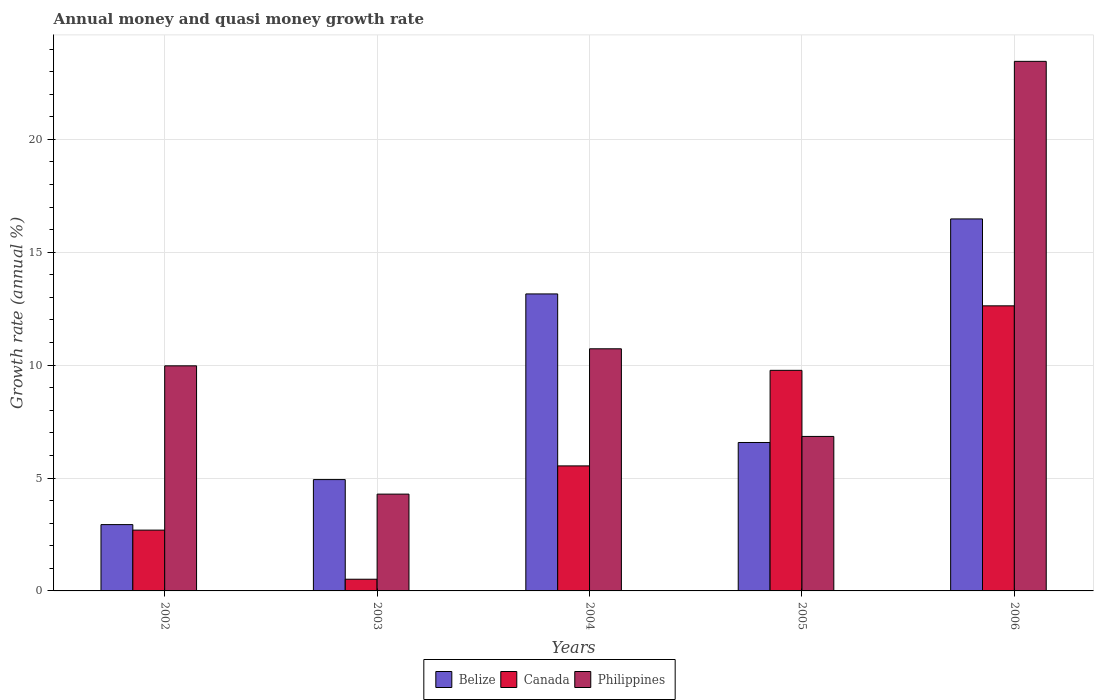How many different coloured bars are there?
Your answer should be very brief. 3. How many groups of bars are there?
Keep it short and to the point. 5. Are the number of bars on each tick of the X-axis equal?
Offer a very short reply. Yes. How many bars are there on the 1st tick from the left?
Offer a terse response. 3. How many bars are there on the 3rd tick from the right?
Provide a succinct answer. 3. What is the label of the 1st group of bars from the left?
Provide a short and direct response. 2002. In how many cases, is the number of bars for a given year not equal to the number of legend labels?
Provide a succinct answer. 0. What is the growth rate in Philippines in 2005?
Your answer should be very brief. 6.84. Across all years, what is the maximum growth rate in Canada?
Your answer should be compact. 12.63. Across all years, what is the minimum growth rate in Canada?
Keep it short and to the point. 0.52. In which year was the growth rate in Belize maximum?
Your answer should be very brief. 2006. In which year was the growth rate in Belize minimum?
Ensure brevity in your answer.  2002. What is the total growth rate in Belize in the graph?
Offer a terse response. 44.07. What is the difference between the growth rate in Philippines in 2002 and that in 2006?
Offer a very short reply. -13.49. What is the difference between the growth rate in Philippines in 2005 and the growth rate in Canada in 2004?
Provide a short and direct response. 1.3. What is the average growth rate in Philippines per year?
Offer a terse response. 11.05. In the year 2006, what is the difference between the growth rate in Canada and growth rate in Belize?
Your answer should be compact. -3.85. What is the ratio of the growth rate in Belize in 2004 to that in 2006?
Offer a very short reply. 0.8. Is the growth rate in Philippines in 2003 less than that in 2006?
Your answer should be very brief. Yes. What is the difference between the highest and the second highest growth rate in Canada?
Offer a terse response. 2.86. What is the difference between the highest and the lowest growth rate in Canada?
Keep it short and to the point. 12.11. In how many years, is the growth rate in Canada greater than the average growth rate in Canada taken over all years?
Your response must be concise. 2. What does the 1st bar from the left in 2005 represents?
Your answer should be compact. Belize. How many bars are there?
Your response must be concise. 15. Are all the bars in the graph horizontal?
Provide a succinct answer. No. How many years are there in the graph?
Make the answer very short. 5. Are the values on the major ticks of Y-axis written in scientific E-notation?
Offer a very short reply. No. Does the graph contain grids?
Offer a very short reply. Yes. Where does the legend appear in the graph?
Ensure brevity in your answer.  Bottom center. What is the title of the graph?
Give a very brief answer. Annual money and quasi money growth rate. Does "Ethiopia" appear as one of the legend labels in the graph?
Provide a short and direct response. No. What is the label or title of the X-axis?
Your answer should be very brief. Years. What is the label or title of the Y-axis?
Ensure brevity in your answer.  Growth rate (annual %). What is the Growth rate (annual %) in Belize in 2002?
Offer a very short reply. 2.94. What is the Growth rate (annual %) in Canada in 2002?
Offer a terse response. 2.69. What is the Growth rate (annual %) of Philippines in 2002?
Give a very brief answer. 9.97. What is the Growth rate (annual %) of Belize in 2003?
Offer a terse response. 4.93. What is the Growth rate (annual %) of Canada in 2003?
Offer a terse response. 0.52. What is the Growth rate (annual %) of Philippines in 2003?
Your response must be concise. 4.29. What is the Growth rate (annual %) of Belize in 2004?
Your answer should be compact. 13.15. What is the Growth rate (annual %) of Canada in 2004?
Your answer should be very brief. 5.54. What is the Growth rate (annual %) in Philippines in 2004?
Offer a terse response. 10.72. What is the Growth rate (annual %) of Belize in 2005?
Offer a very short reply. 6.57. What is the Growth rate (annual %) in Canada in 2005?
Your answer should be very brief. 9.77. What is the Growth rate (annual %) in Philippines in 2005?
Ensure brevity in your answer.  6.84. What is the Growth rate (annual %) in Belize in 2006?
Your response must be concise. 16.48. What is the Growth rate (annual %) of Canada in 2006?
Your response must be concise. 12.63. What is the Growth rate (annual %) of Philippines in 2006?
Offer a very short reply. 23.45. Across all years, what is the maximum Growth rate (annual %) in Belize?
Offer a terse response. 16.48. Across all years, what is the maximum Growth rate (annual %) in Canada?
Your response must be concise. 12.63. Across all years, what is the maximum Growth rate (annual %) in Philippines?
Offer a very short reply. 23.45. Across all years, what is the minimum Growth rate (annual %) in Belize?
Ensure brevity in your answer.  2.94. Across all years, what is the minimum Growth rate (annual %) of Canada?
Give a very brief answer. 0.52. Across all years, what is the minimum Growth rate (annual %) in Philippines?
Your response must be concise. 4.29. What is the total Growth rate (annual %) in Belize in the graph?
Provide a succinct answer. 44.07. What is the total Growth rate (annual %) in Canada in the graph?
Your answer should be compact. 31.14. What is the total Growth rate (annual %) of Philippines in the graph?
Your response must be concise. 55.27. What is the difference between the Growth rate (annual %) of Belize in 2002 and that in 2003?
Provide a short and direct response. -1.99. What is the difference between the Growth rate (annual %) in Canada in 2002 and that in 2003?
Give a very brief answer. 2.18. What is the difference between the Growth rate (annual %) of Philippines in 2002 and that in 2003?
Provide a succinct answer. 5.68. What is the difference between the Growth rate (annual %) of Belize in 2002 and that in 2004?
Ensure brevity in your answer.  -10.22. What is the difference between the Growth rate (annual %) in Canada in 2002 and that in 2004?
Provide a succinct answer. -2.84. What is the difference between the Growth rate (annual %) in Philippines in 2002 and that in 2004?
Offer a terse response. -0.75. What is the difference between the Growth rate (annual %) in Belize in 2002 and that in 2005?
Keep it short and to the point. -3.64. What is the difference between the Growth rate (annual %) in Canada in 2002 and that in 2005?
Your answer should be compact. -7.08. What is the difference between the Growth rate (annual %) of Philippines in 2002 and that in 2005?
Ensure brevity in your answer.  3.13. What is the difference between the Growth rate (annual %) of Belize in 2002 and that in 2006?
Give a very brief answer. -13.54. What is the difference between the Growth rate (annual %) of Canada in 2002 and that in 2006?
Your answer should be compact. -9.93. What is the difference between the Growth rate (annual %) of Philippines in 2002 and that in 2006?
Offer a terse response. -13.49. What is the difference between the Growth rate (annual %) in Belize in 2003 and that in 2004?
Make the answer very short. -8.22. What is the difference between the Growth rate (annual %) in Canada in 2003 and that in 2004?
Keep it short and to the point. -5.02. What is the difference between the Growth rate (annual %) of Philippines in 2003 and that in 2004?
Give a very brief answer. -6.44. What is the difference between the Growth rate (annual %) of Belize in 2003 and that in 2005?
Offer a terse response. -1.64. What is the difference between the Growth rate (annual %) in Canada in 2003 and that in 2005?
Make the answer very short. -9.25. What is the difference between the Growth rate (annual %) in Philippines in 2003 and that in 2005?
Provide a succinct answer. -2.55. What is the difference between the Growth rate (annual %) in Belize in 2003 and that in 2006?
Make the answer very short. -11.54. What is the difference between the Growth rate (annual %) of Canada in 2003 and that in 2006?
Keep it short and to the point. -12.11. What is the difference between the Growth rate (annual %) in Philippines in 2003 and that in 2006?
Make the answer very short. -19.17. What is the difference between the Growth rate (annual %) in Belize in 2004 and that in 2005?
Keep it short and to the point. 6.58. What is the difference between the Growth rate (annual %) of Canada in 2004 and that in 2005?
Keep it short and to the point. -4.23. What is the difference between the Growth rate (annual %) of Philippines in 2004 and that in 2005?
Ensure brevity in your answer.  3.88. What is the difference between the Growth rate (annual %) of Belize in 2004 and that in 2006?
Give a very brief answer. -3.32. What is the difference between the Growth rate (annual %) in Canada in 2004 and that in 2006?
Offer a terse response. -7.09. What is the difference between the Growth rate (annual %) in Philippines in 2004 and that in 2006?
Offer a terse response. -12.73. What is the difference between the Growth rate (annual %) in Belize in 2005 and that in 2006?
Give a very brief answer. -9.9. What is the difference between the Growth rate (annual %) of Canada in 2005 and that in 2006?
Offer a very short reply. -2.86. What is the difference between the Growth rate (annual %) in Philippines in 2005 and that in 2006?
Your answer should be compact. -16.61. What is the difference between the Growth rate (annual %) of Belize in 2002 and the Growth rate (annual %) of Canada in 2003?
Your response must be concise. 2.42. What is the difference between the Growth rate (annual %) in Belize in 2002 and the Growth rate (annual %) in Philippines in 2003?
Your answer should be very brief. -1.35. What is the difference between the Growth rate (annual %) in Canada in 2002 and the Growth rate (annual %) in Philippines in 2003?
Provide a short and direct response. -1.59. What is the difference between the Growth rate (annual %) of Belize in 2002 and the Growth rate (annual %) of Canada in 2004?
Offer a very short reply. -2.6. What is the difference between the Growth rate (annual %) in Belize in 2002 and the Growth rate (annual %) in Philippines in 2004?
Your answer should be very brief. -7.79. What is the difference between the Growth rate (annual %) of Canada in 2002 and the Growth rate (annual %) of Philippines in 2004?
Ensure brevity in your answer.  -8.03. What is the difference between the Growth rate (annual %) in Belize in 2002 and the Growth rate (annual %) in Canada in 2005?
Offer a very short reply. -6.83. What is the difference between the Growth rate (annual %) in Belize in 2002 and the Growth rate (annual %) in Philippines in 2005?
Give a very brief answer. -3.91. What is the difference between the Growth rate (annual %) in Canada in 2002 and the Growth rate (annual %) in Philippines in 2005?
Your answer should be compact. -4.15. What is the difference between the Growth rate (annual %) in Belize in 2002 and the Growth rate (annual %) in Canada in 2006?
Your response must be concise. -9.69. What is the difference between the Growth rate (annual %) in Belize in 2002 and the Growth rate (annual %) in Philippines in 2006?
Ensure brevity in your answer.  -20.52. What is the difference between the Growth rate (annual %) of Canada in 2002 and the Growth rate (annual %) of Philippines in 2006?
Provide a succinct answer. -20.76. What is the difference between the Growth rate (annual %) of Belize in 2003 and the Growth rate (annual %) of Canada in 2004?
Your answer should be compact. -0.61. What is the difference between the Growth rate (annual %) in Belize in 2003 and the Growth rate (annual %) in Philippines in 2004?
Offer a very short reply. -5.79. What is the difference between the Growth rate (annual %) in Canada in 2003 and the Growth rate (annual %) in Philippines in 2004?
Make the answer very short. -10.21. What is the difference between the Growth rate (annual %) of Belize in 2003 and the Growth rate (annual %) of Canada in 2005?
Your response must be concise. -4.84. What is the difference between the Growth rate (annual %) in Belize in 2003 and the Growth rate (annual %) in Philippines in 2005?
Your response must be concise. -1.91. What is the difference between the Growth rate (annual %) of Canada in 2003 and the Growth rate (annual %) of Philippines in 2005?
Offer a very short reply. -6.32. What is the difference between the Growth rate (annual %) of Belize in 2003 and the Growth rate (annual %) of Canada in 2006?
Your answer should be compact. -7.69. What is the difference between the Growth rate (annual %) in Belize in 2003 and the Growth rate (annual %) in Philippines in 2006?
Ensure brevity in your answer.  -18.52. What is the difference between the Growth rate (annual %) in Canada in 2003 and the Growth rate (annual %) in Philippines in 2006?
Your answer should be very brief. -22.94. What is the difference between the Growth rate (annual %) of Belize in 2004 and the Growth rate (annual %) of Canada in 2005?
Ensure brevity in your answer.  3.38. What is the difference between the Growth rate (annual %) in Belize in 2004 and the Growth rate (annual %) in Philippines in 2005?
Keep it short and to the point. 6.31. What is the difference between the Growth rate (annual %) in Canada in 2004 and the Growth rate (annual %) in Philippines in 2005?
Keep it short and to the point. -1.3. What is the difference between the Growth rate (annual %) in Belize in 2004 and the Growth rate (annual %) in Canada in 2006?
Keep it short and to the point. 0.53. What is the difference between the Growth rate (annual %) of Belize in 2004 and the Growth rate (annual %) of Philippines in 2006?
Make the answer very short. -10.3. What is the difference between the Growth rate (annual %) of Canada in 2004 and the Growth rate (annual %) of Philippines in 2006?
Provide a succinct answer. -17.92. What is the difference between the Growth rate (annual %) of Belize in 2005 and the Growth rate (annual %) of Canada in 2006?
Make the answer very short. -6.05. What is the difference between the Growth rate (annual %) in Belize in 2005 and the Growth rate (annual %) in Philippines in 2006?
Give a very brief answer. -16.88. What is the difference between the Growth rate (annual %) in Canada in 2005 and the Growth rate (annual %) in Philippines in 2006?
Your answer should be very brief. -13.68. What is the average Growth rate (annual %) in Belize per year?
Give a very brief answer. 8.81. What is the average Growth rate (annual %) in Canada per year?
Your answer should be very brief. 6.23. What is the average Growth rate (annual %) of Philippines per year?
Your answer should be compact. 11.05. In the year 2002, what is the difference between the Growth rate (annual %) in Belize and Growth rate (annual %) in Canada?
Provide a short and direct response. 0.24. In the year 2002, what is the difference between the Growth rate (annual %) in Belize and Growth rate (annual %) in Philippines?
Keep it short and to the point. -7.03. In the year 2002, what is the difference between the Growth rate (annual %) in Canada and Growth rate (annual %) in Philippines?
Make the answer very short. -7.28. In the year 2003, what is the difference between the Growth rate (annual %) in Belize and Growth rate (annual %) in Canada?
Keep it short and to the point. 4.41. In the year 2003, what is the difference between the Growth rate (annual %) in Belize and Growth rate (annual %) in Philippines?
Your answer should be very brief. 0.64. In the year 2003, what is the difference between the Growth rate (annual %) of Canada and Growth rate (annual %) of Philippines?
Offer a very short reply. -3.77. In the year 2004, what is the difference between the Growth rate (annual %) in Belize and Growth rate (annual %) in Canada?
Your answer should be compact. 7.62. In the year 2004, what is the difference between the Growth rate (annual %) of Belize and Growth rate (annual %) of Philippines?
Give a very brief answer. 2.43. In the year 2004, what is the difference between the Growth rate (annual %) in Canada and Growth rate (annual %) in Philippines?
Provide a short and direct response. -5.19. In the year 2005, what is the difference between the Growth rate (annual %) in Belize and Growth rate (annual %) in Canada?
Ensure brevity in your answer.  -3.2. In the year 2005, what is the difference between the Growth rate (annual %) in Belize and Growth rate (annual %) in Philippines?
Your response must be concise. -0.27. In the year 2005, what is the difference between the Growth rate (annual %) of Canada and Growth rate (annual %) of Philippines?
Your response must be concise. 2.93. In the year 2006, what is the difference between the Growth rate (annual %) of Belize and Growth rate (annual %) of Canada?
Your response must be concise. 3.85. In the year 2006, what is the difference between the Growth rate (annual %) of Belize and Growth rate (annual %) of Philippines?
Your answer should be very brief. -6.98. In the year 2006, what is the difference between the Growth rate (annual %) in Canada and Growth rate (annual %) in Philippines?
Give a very brief answer. -10.83. What is the ratio of the Growth rate (annual %) of Belize in 2002 to that in 2003?
Provide a succinct answer. 0.6. What is the ratio of the Growth rate (annual %) of Canada in 2002 to that in 2003?
Provide a short and direct response. 5.2. What is the ratio of the Growth rate (annual %) of Philippines in 2002 to that in 2003?
Provide a short and direct response. 2.33. What is the ratio of the Growth rate (annual %) in Belize in 2002 to that in 2004?
Offer a very short reply. 0.22. What is the ratio of the Growth rate (annual %) in Canada in 2002 to that in 2004?
Your answer should be compact. 0.49. What is the ratio of the Growth rate (annual %) of Philippines in 2002 to that in 2004?
Ensure brevity in your answer.  0.93. What is the ratio of the Growth rate (annual %) in Belize in 2002 to that in 2005?
Provide a succinct answer. 0.45. What is the ratio of the Growth rate (annual %) of Canada in 2002 to that in 2005?
Your response must be concise. 0.28. What is the ratio of the Growth rate (annual %) in Philippines in 2002 to that in 2005?
Provide a short and direct response. 1.46. What is the ratio of the Growth rate (annual %) of Belize in 2002 to that in 2006?
Give a very brief answer. 0.18. What is the ratio of the Growth rate (annual %) in Canada in 2002 to that in 2006?
Make the answer very short. 0.21. What is the ratio of the Growth rate (annual %) in Philippines in 2002 to that in 2006?
Give a very brief answer. 0.42. What is the ratio of the Growth rate (annual %) in Belize in 2003 to that in 2004?
Your answer should be compact. 0.37. What is the ratio of the Growth rate (annual %) in Canada in 2003 to that in 2004?
Provide a succinct answer. 0.09. What is the ratio of the Growth rate (annual %) of Philippines in 2003 to that in 2004?
Offer a terse response. 0.4. What is the ratio of the Growth rate (annual %) of Belize in 2003 to that in 2005?
Give a very brief answer. 0.75. What is the ratio of the Growth rate (annual %) of Canada in 2003 to that in 2005?
Offer a terse response. 0.05. What is the ratio of the Growth rate (annual %) of Philippines in 2003 to that in 2005?
Your response must be concise. 0.63. What is the ratio of the Growth rate (annual %) in Belize in 2003 to that in 2006?
Offer a very short reply. 0.3. What is the ratio of the Growth rate (annual %) in Canada in 2003 to that in 2006?
Provide a short and direct response. 0.04. What is the ratio of the Growth rate (annual %) in Philippines in 2003 to that in 2006?
Offer a terse response. 0.18. What is the ratio of the Growth rate (annual %) in Belize in 2004 to that in 2005?
Your answer should be very brief. 2. What is the ratio of the Growth rate (annual %) in Canada in 2004 to that in 2005?
Provide a succinct answer. 0.57. What is the ratio of the Growth rate (annual %) in Philippines in 2004 to that in 2005?
Give a very brief answer. 1.57. What is the ratio of the Growth rate (annual %) of Belize in 2004 to that in 2006?
Provide a succinct answer. 0.8. What is the ratio of the Growth rate (annual %) of Canada in 2004 to that in 2006?
Offer a terse response. 0.44. What is the ratio of the Growth rate (annual %) of Philippines in 2004 to that in 2006?
Keep it short and to the point. 0.46. What is the ratio of the Growth rate (annual %) in Belize in 2005 to that in 2006?
Offer a very short reply. 0.4. What is the ratio of the Growth rate (annual %) in Canada in 2005 to that in 2006?
Provide a short and direct response. 0.77. What is the ratio of the Growth rate (annual %) of Philippines in 2005 to that in 2006?
Your response must be concise. 0.29. What is the difference between the highest and the second highest Growth rate (annual %) in Belize?
Make the answer very short. 3.32. What is the difference between the highest and the second highest Growth rate (annual %) in Canada?
Your answer should be compact. 2.86. What is the difference between the highest and the second highest Growth rate (annual %) in Philippines?
Your answer should be compact. 12.73. What is the difference between the highest and the lowest Growth rate (annual %) in Belize?
Your answer should be very brief. 13.54. What is the difference between the highest and the lowest Growth rate (annual %) of Canada?
Provide a short and direct response. 12.11. What is the difference between the highest and the lowest Growth rate (annual %) of Philippines?
Offer a very short reply. 19.17. 